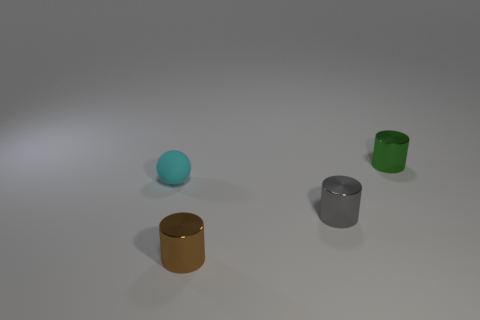Subtract all small green shiny cylinders. How many cylinders are left? 2 Subtract all gray cylinders. How many cylinders are left? 2 Add 2 tiny gray objects. How many objects exist? 6 Subtract all cylinders. How many objects are left? 1 Subtract 1 gray cylinders. How many objects are left? 3 Subtract 1 cylinders. How many cylinders are left? 2 Subtract all yellow cylinders. Subtract all red spheres. How many cylinders are left? 3 Subtract all purple cubes. How many yellow balls are left? 0 Subtract all big yellow shiny cylinders. Subtract all shiny things. How many objects are left? 1 Add 1 small gray objects. How many small gray objects are left? 2 